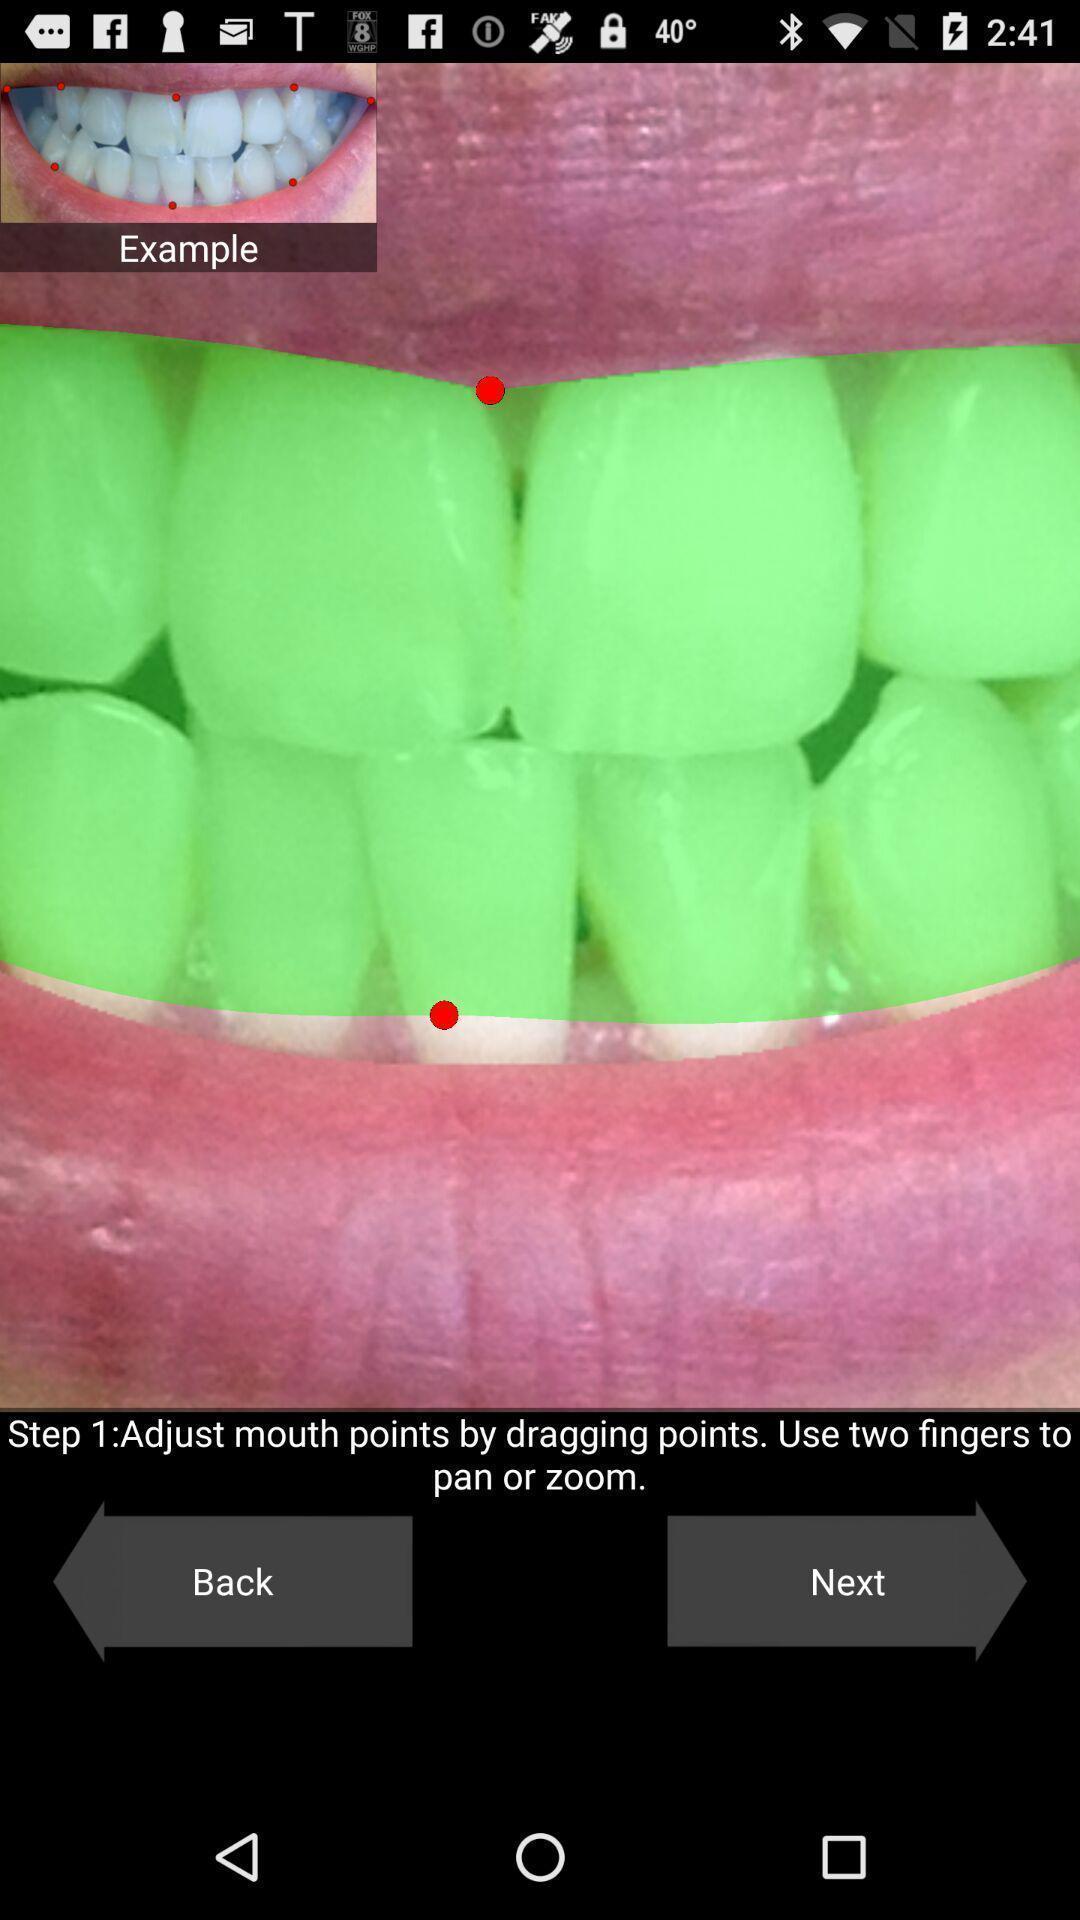What details can you identify in this image? Screen displaying the teeth page. 